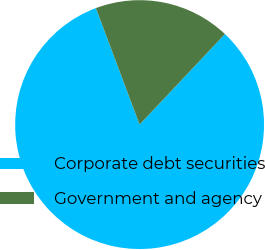Convert chart to OTSL. <chart><loc_0><loc_0><loc_500><loc_500><pie_chart><fcel>Corporate debt securities<fcel>Government and agency<nl><fcel>82.26%<fcel>17.74%<nl></chart> 